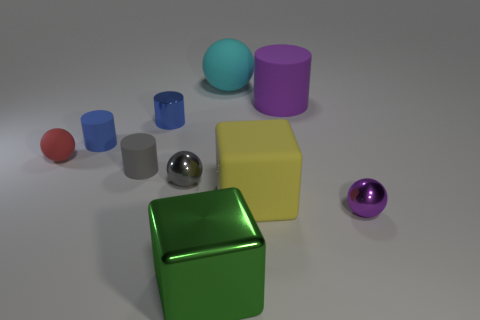Does the purple cylinder have the same size as the thing in front of the purple metal thing?
Offer a very short reply. Yes. There is a object in front of the metallic ball on the right side of the metallic ball to the left of the large metal object; what is its shape?
Your answer should be compact. Cube. Are there fewer shiny objects than large yellow cubes?
Give a very brief answer. No. Are there any red things behind the big cylinder?
Offer a terse response. No. There is a large object that is in front of the red sphere and to the right of the large cyan matte sphere; what shape is it?
Make the answer very short. Cube. Are there any tiny objects of the same shape as the large purple object?
Give a very brief answer. Yes. Does the cube that is behind the large green shiny cube have the same size as the purple object behind the gray ball?
Offer a terse response. Yes. Is the number of large cylinders greater than the number of red shiny blocks?
Give a very brief answer. Yes. What number of tiny cylinders have the same material as the large green cube?
Offer a very short reply. 1. Does the purple rubber thing have the same shape as the small red rubber thing?
Your response must be concise. No. 